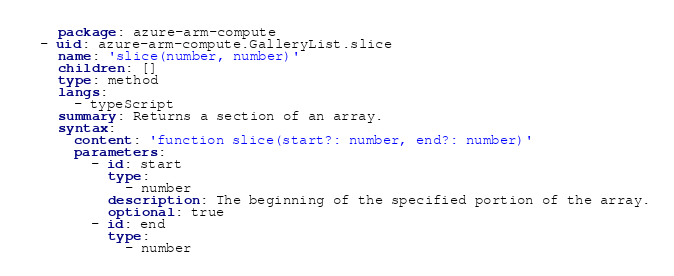<code> <loc_0><loc_0><loc_500><loc_500><_YAML_>    package: azure-arm-compute
  - uid: azure-arm-compute.GalleryList.slice
    name: 'slice(number, number)'
    children: []
    type: method
    langs:
      - typeScript
    summary: Returns a section of an array.
    syntax:
      content: 'function slice(start?: number, end?: number)'
      parameters:
        - id: start
          type:
            - number
          description: The beginning of the specified portion of the array.
          optional: true
        - id: end
          type:
            - number</code> 